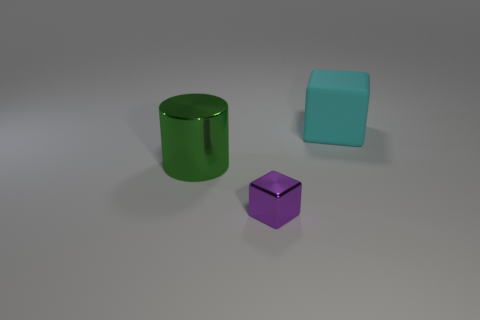What lighting conditions are present in this image? The lighting in the image is soft and diffused, with no harsh shadows or bright spots. It gives the scene a calm, even tone and suggests the light source is not direct but spread out, possibly coming from an overhead light or through a filter. 